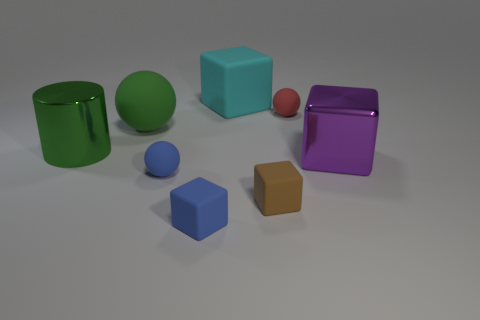Does the red sphere have the same size as the blue object behind the small brown matte block?
Give a very brief answer. Yes. There is a sphere that is the same color as the metal cylinder; what material is it?
Your answer should be very brief. Rubber. How big is the metallic thing left of the large block behind the small rubber sphere that is behind the big green rubber object?
Give a very brief answer. Large. Are there more tiny red rubber objects that are behind the small blue block than blue things right of the cyan thing?
Provide a succinct answer. Yes. There is a object on the left side of the green rubber thing; how many large green cylinders are behind it?
Make the answer very short. 0. Are there any other large cylinders that have the same color as the cylinder?
Keep it short and to the point. No. Do the purple block and the blue rubber ball have the same size?
Offer a terse response. No. Is the color of the large matte cube the same as the large metal cylinder?
Offer a very short reply. No. There is a tiny cube that is on the left side of the cube behind the large metallic block; what is it made of?
Make the answer very short. Rubber. There is a blue object that is the same shape as the green matte object; what is it made of?
Your response must be concise. Rubber. 